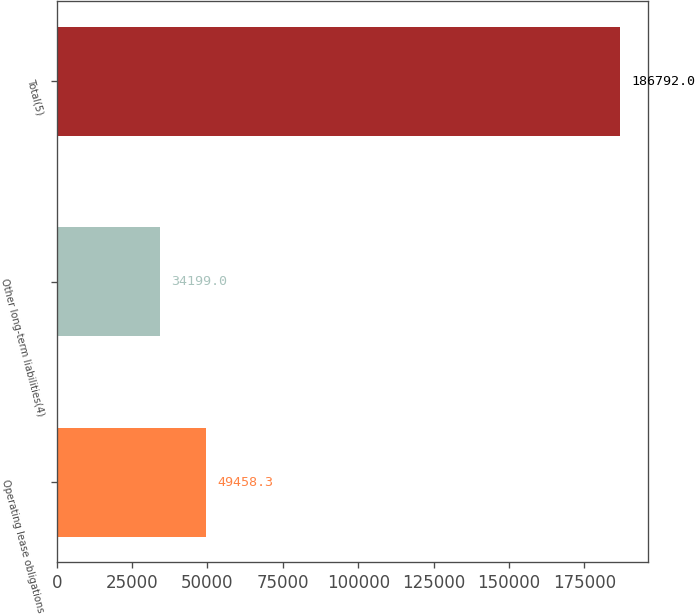<chart> <loc_0><loc_0><loc_500><loc_500><bar_chart><fcel>Operating lease obligations<fcel>Other long-term liabilities(4)<fcel>Total(5)<nl><fcel>49458.3<fcel>34199<fcel>186792<nl></chart> 